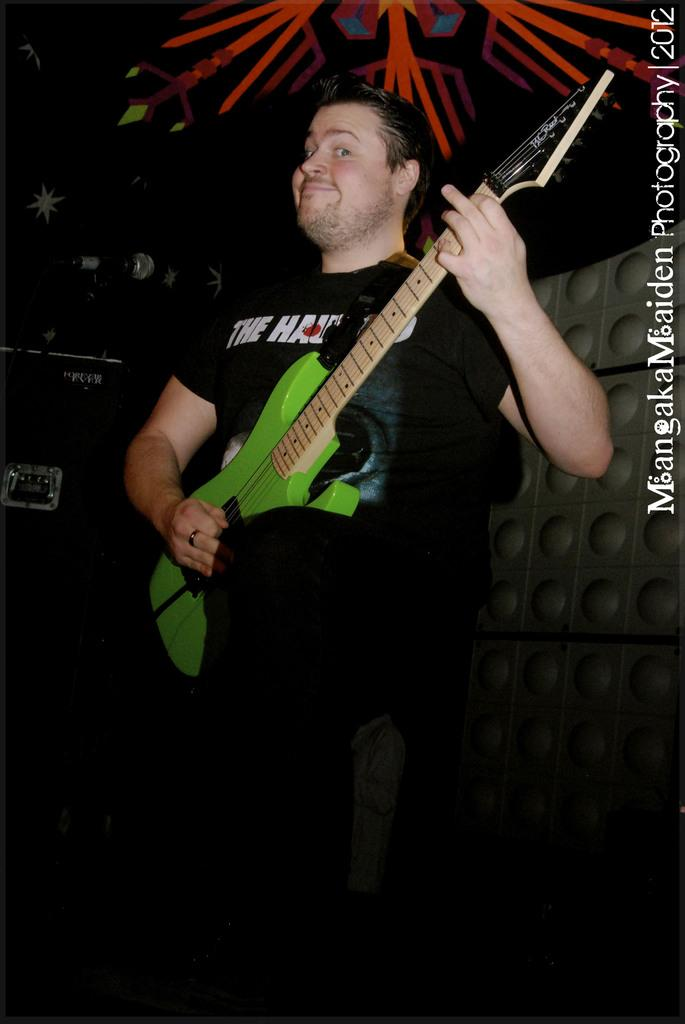What is the person in the image doing? The person is playing a guitar. What object is in front of the person? There is a microphone in front of the person. Can you describe the watermark in the image? The watermark is on the right side of the image. What can be seen in the background of the image? The background of the image includes strips and a wall. What type of writing is visible on the wall in the image? There is no writing visible on the wall in the image. 